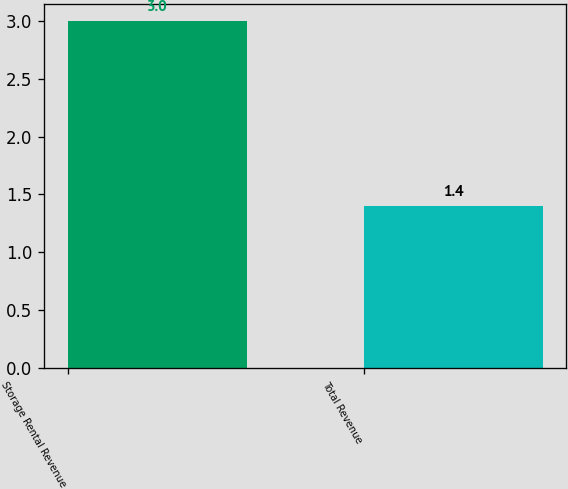<chart> <loc_0><loc_0><loc_500><loc_500><bar_chart><fcel>Storage Rental Revenue<fcel>Total Revenue<nl><fcel>3<fcel>1.4<nl></chart> 